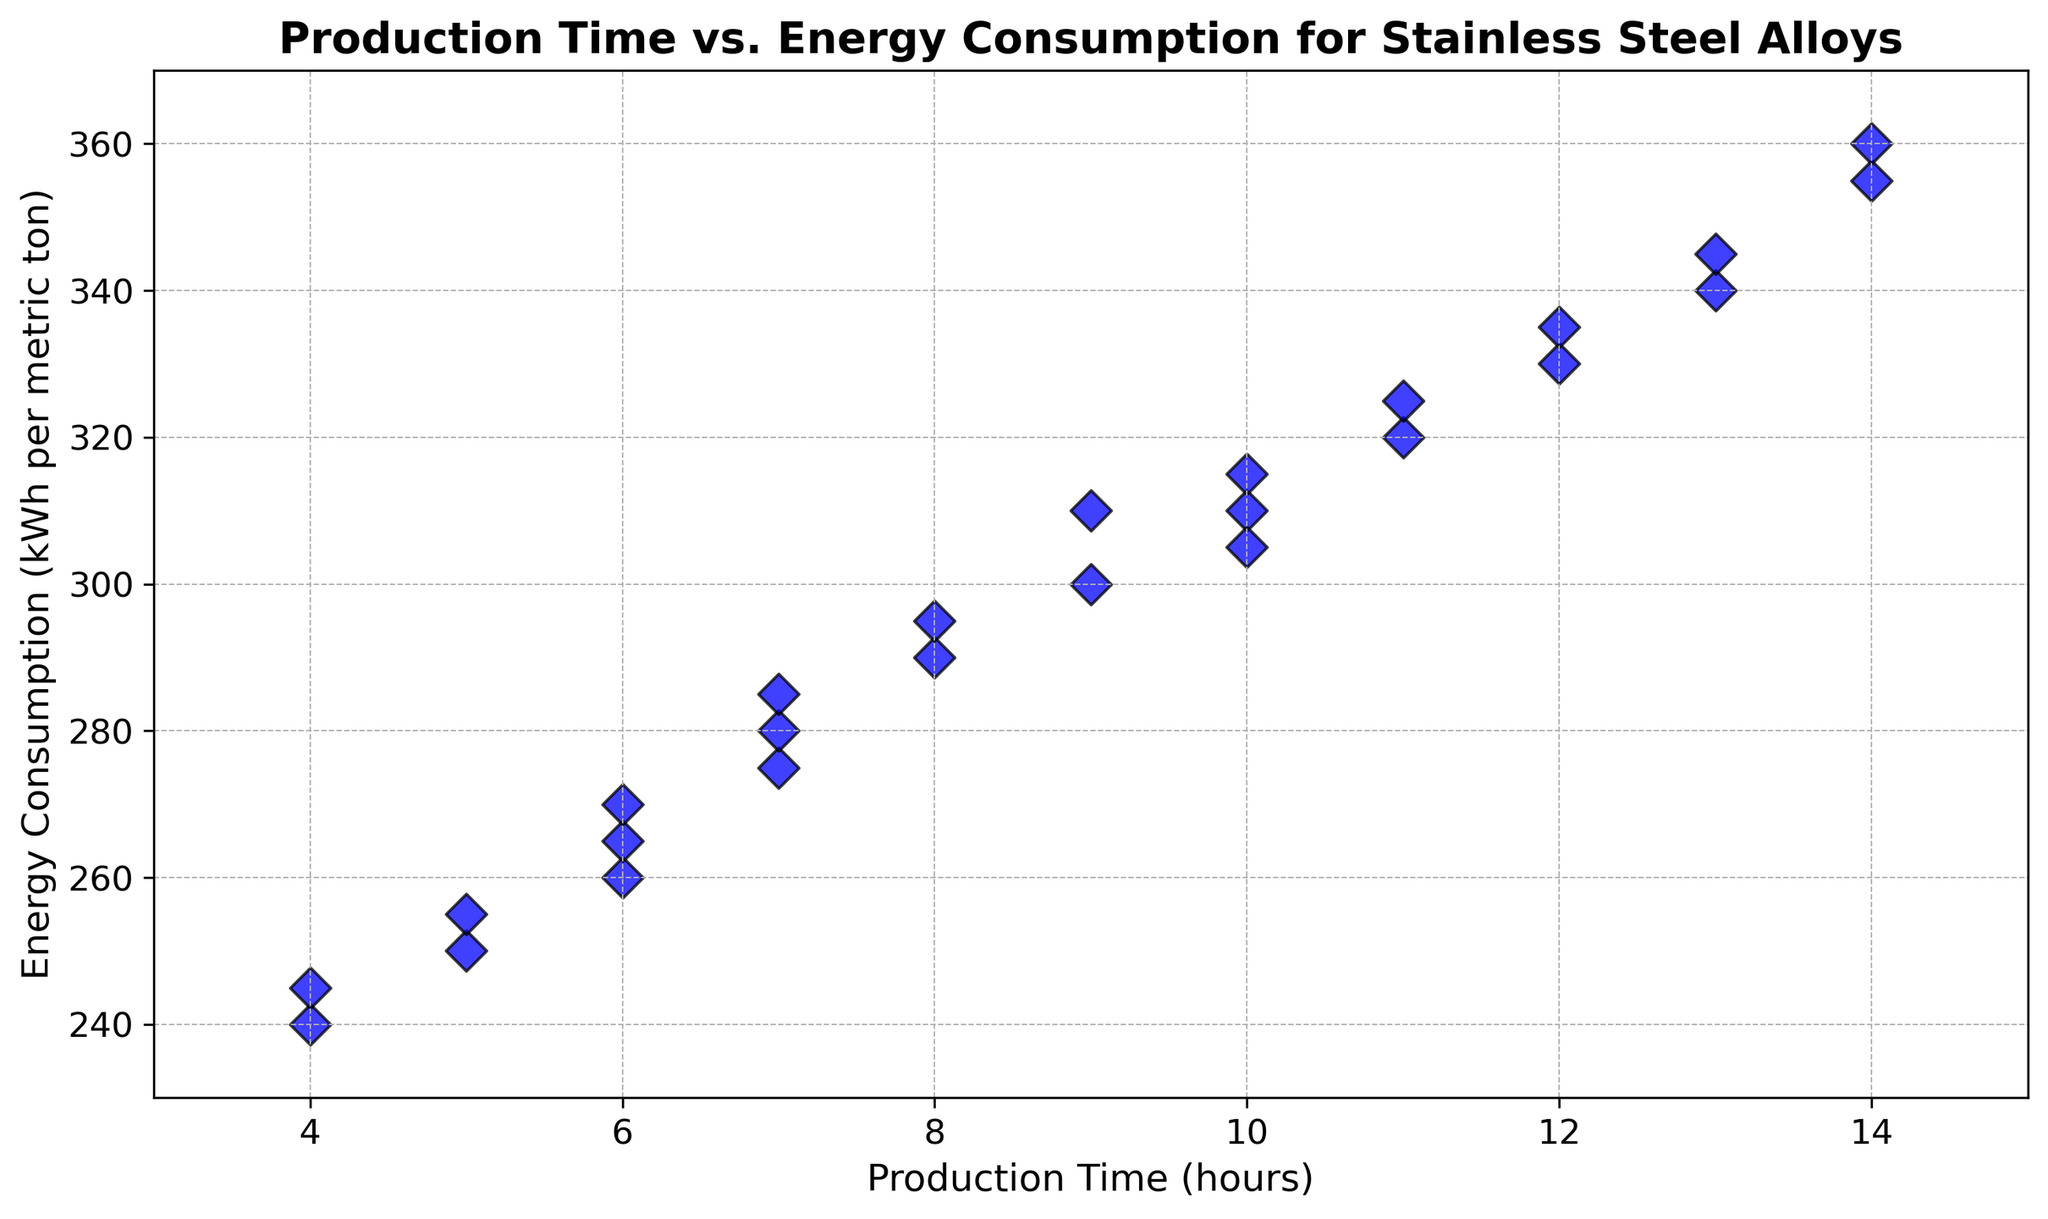What's the average energy consumption for production times greater than 10 hours? First, identify the production times greater than 10 hours: 12, 11, 13, 14. The corresponding energy consumption values are 330, 320, 340, 355. Sum these values: 330 + 320 + 340 + 355 = 1345. Then, divide by the number of values: 1345 / 4 = 336.25
Answer: 336.25 Which data point has the lowest energy consumption and what is its production time? Look at all the energy consumption values and identify the lowest one which is 240 kWh per metric ton. The corresponding production time for this value is 4 hours
Answer: 240 kWh, 4 hours Is there a positive correlation between production time and energy consumption? From the scatter plot, observe that as production time increases, energy consumption generally increases as well, indicating a positive correlation
Answer: Yes What are the maximum values for both production time and energy consumption? Identify the maximum values on both axes in the scatter plot. The highest production time is 14 hours, and the highest energy consumption is 360 kWh per metric ton
Answer: 14 hours, 360 kWh For production times of 6 hours, what is the range of energy consumption values? Find the energy consumption values corresponding to production times of 6 hours: 260, 265, 270. Subtract the smallest value from the largest value: 270 - 260 = 10 kWh
Answer: 10 kWh Compare the energy consumption for production times of 7 hours and 9 hours. Which has a higher average energy consumption? Average energy consumption for 7 hours: (275 + 280 + 285)/3 = 840/3 = 280 kWh. Average energy consumption for 9 hours: (300 + 310)/2 = 610/2 = 305 kWh. Thus, 9 hours has a higher average energy consumption
Answer: 9 hours What is the median energy consumption for all the data points? Sort the energy consumption values and find the middle value in the ordered list: 240, 245, 250, 255, 260, 265, 270, 275, 280, 285, 290, 295, 300, 305, 310, 310, 315, 320, 325, 330, 335, 340, 345, 355, 360. The middle value (13th in this sorted list) is 300 kWh
Answer: 300 kWh Identify any outliers in the data. An outlier can be a value that is distinctly separate from the cluster of other values. Review the scatter plot to identify any points that are noticeably isolated from the general trend. The points at (4, 240) and perhaps (14, 360) appear as potential outliers given how they stand apart
Answer: (4, 240), (14, 360) How does energy consumption change from 10 hours to 12 hours of production time? Find the energy consumption for 10 hours, 11 hours, and 12 hours: 310, 320, 330. Note that energy consumption increases by 10 kWh each hour from 10 to 12 hours
Answer: Increases by 10 kWh per hour 